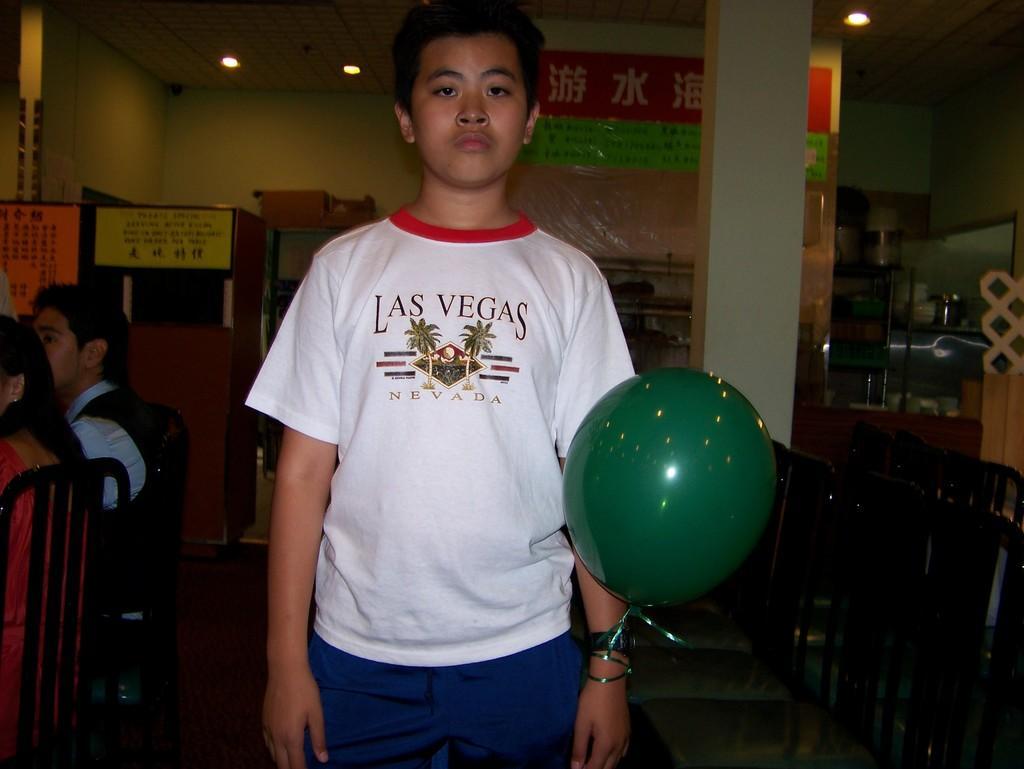Could you give a brief overview of what you see in this image? In this picture there is a boy in the center of the image, by holding a balloon in his hand, there are people those who are sitting on the chairs on the left side of the image and there are chairs on the right side of the image and there posters and a rack, which contains utensils in the background area of the image, there are lamps at the top side of the image. 